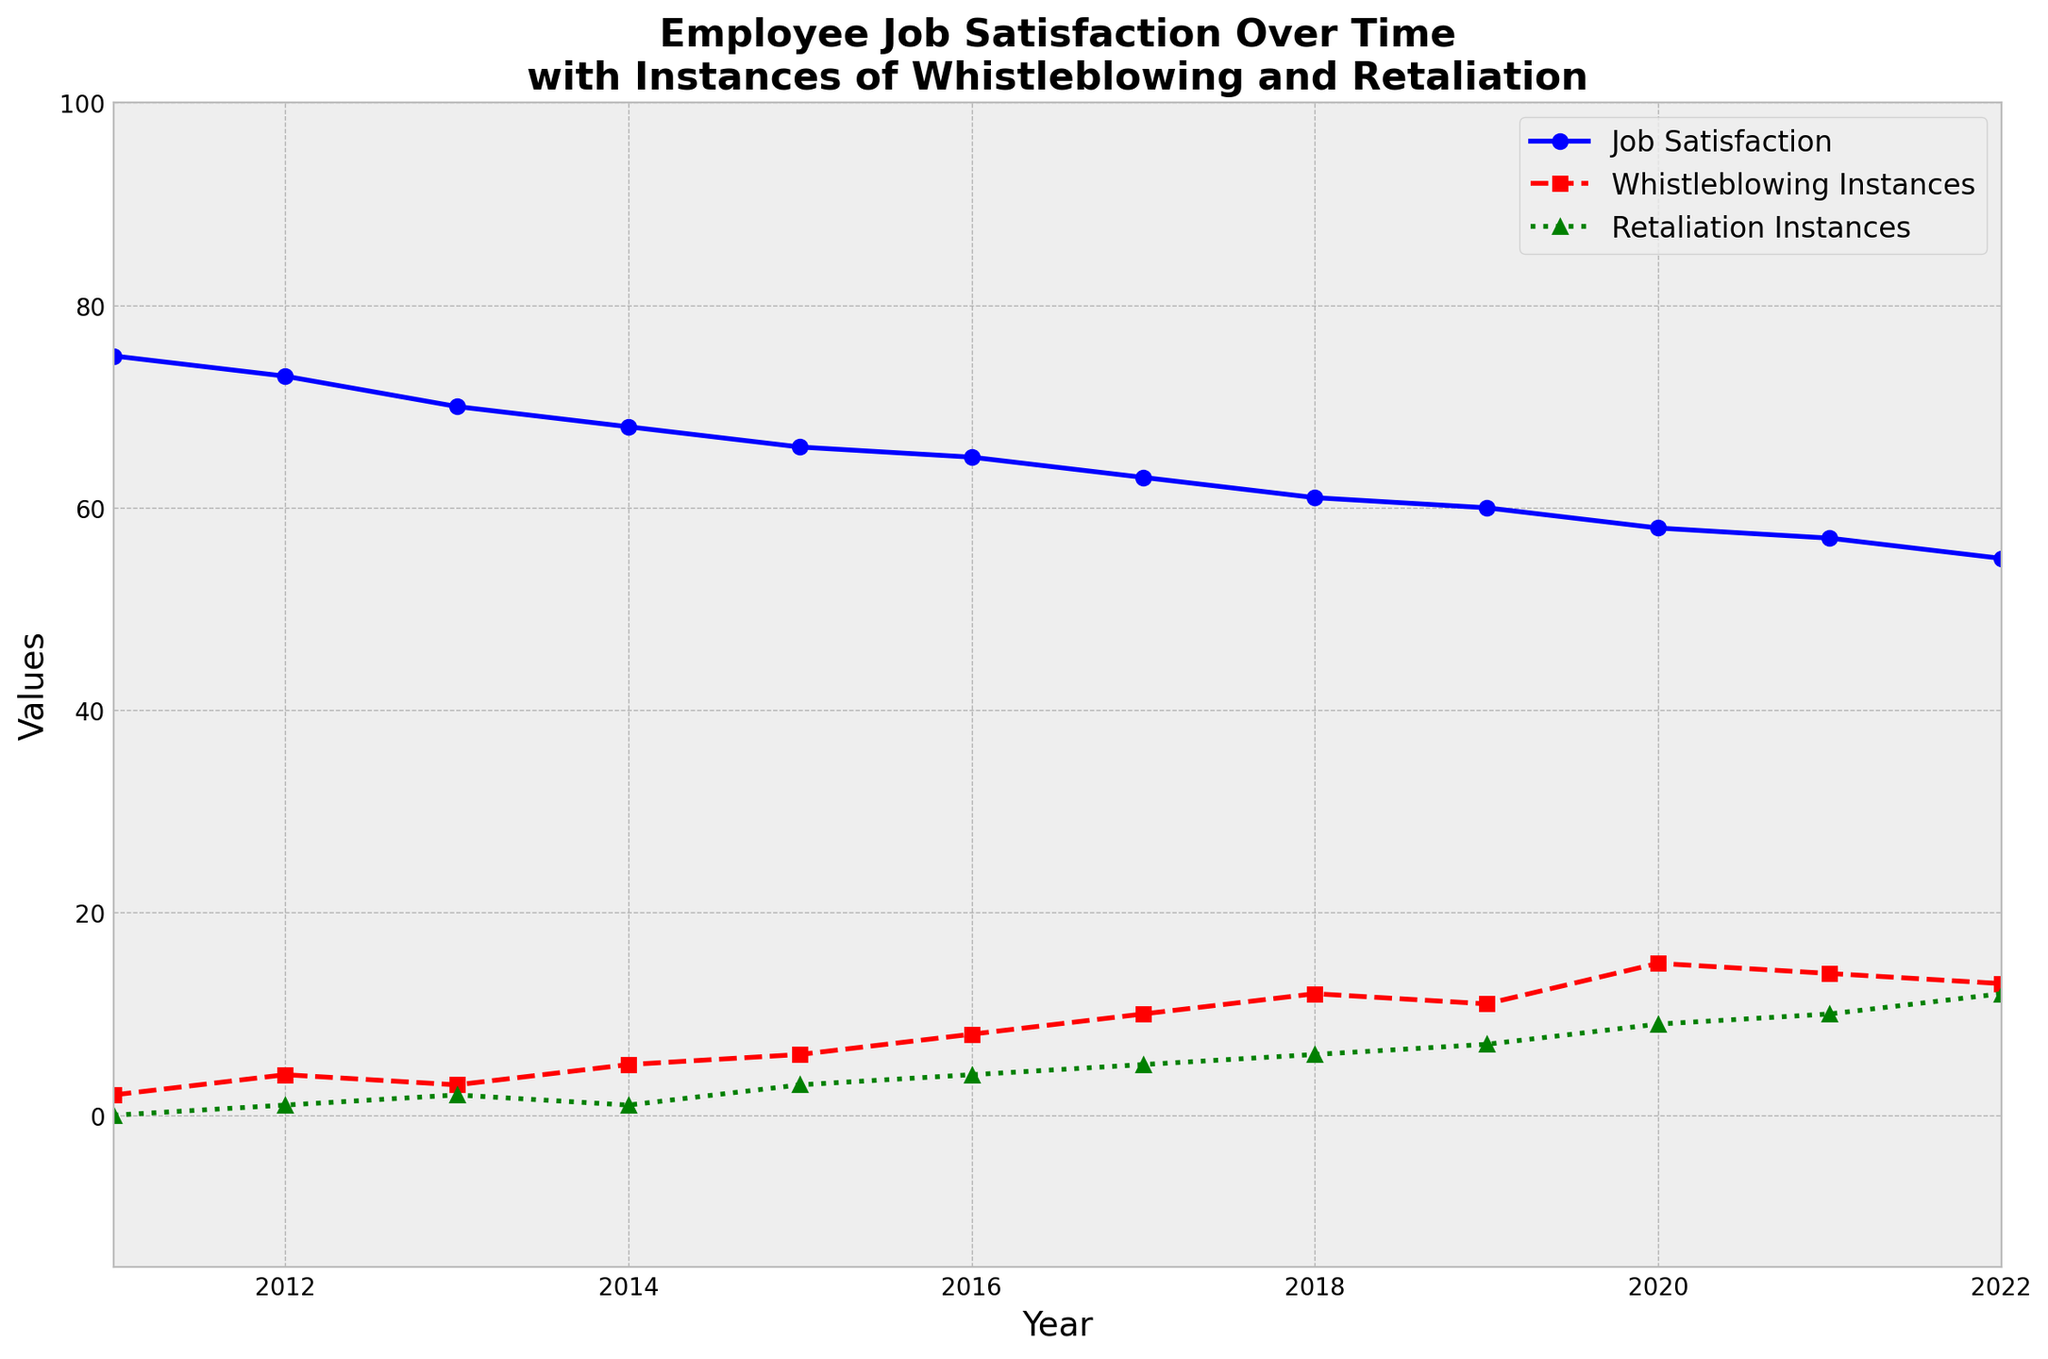What's the trend of Job Satisfaction from 2011 to 2022? Job Satisfaction shows a decreasing trend from around 75 in 2011 to 55 in 2022. It steadily declines each year, indicating a drop in satisfaction over the period.
Answer: Decreasing How does the number of Whistleblowing Instances in 2022 compare to 2011? Whistleblowing Instances increases from 2 in 2011 to 13 in 2022. This clearly shows an upward trend in whistleblowing over the years.
Answer: Increased In which year did Retaliation Instances start to rise significantly? Retaliation Instances started having noticeable values from 2012 onward. It shows more significant increases from 2014 and continues rising more sharply after 2016.
Answer: 2014 Compare the slope of the lines for Whistleblowing Instances and Job Satisfaction. The slope of the Whistleblowing Instances line is positive, indicating an increase, while the slope for Job Satisfaction is negative, indicating a decrease.
Answer: Opposite slopes What's the difference in Job Satisfaction between 2011 and 2022? Job Satisfaction starts at 75 in 2011 and drops to 55 in 2022. The difference is 75 - 55 = 20.
Answer: 20 In which year do Whistleblowing Instances peak? Whistleblowing Instances peak in 2020 with a value of 15.
Answer: 2020 By how much did Retaliation Instances increase from 2015 to 2022? Retaliation Instances increased from 3 in 2015 to 12 in 2022. The increase is 12 - 3 = 9.
Answer: 9 Which year shows the highest number of Retaliation Instances, and what is the exact value? The highest number of Retaliation Instances is in 2022 with a value of 12.
Answer: 2022, 12 In which years are Job Satisfaction and Whistleblowing Instances the closest in value? In 2022, Job Satisfaction is 55 and Whistleblowing Instances is 13, which is the closest in relative scale difference throughout the years.
Answer: 2022 What general relationship can be inferred between Job Satisfaction and Whistleblowing Instances over time? As Job Satisfaction decreases, Whistleblowing Instances tend to increase, suggesting a possible negative correlation.
Answer: Negative correlation 